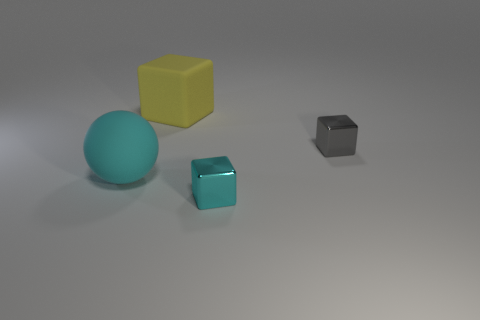Subtract all purple cubes. Subtract all green spheres. How many cubes are left? 3 Add 1 big brown matte spheres. How many objects exist? 5 Subtract all spheres. How many objects are left? 3 Subtract all matte things. Subtract all big cyan matte balls. How many objects are left? 1 Add 2 cyan metallic blocks. How many cyan metallic blocks are left? 3 Add 1 large yellow rubber things. How many large yellow rubber things exist? 2 Subtract 0 green cylinders. How many objects are left? 4 